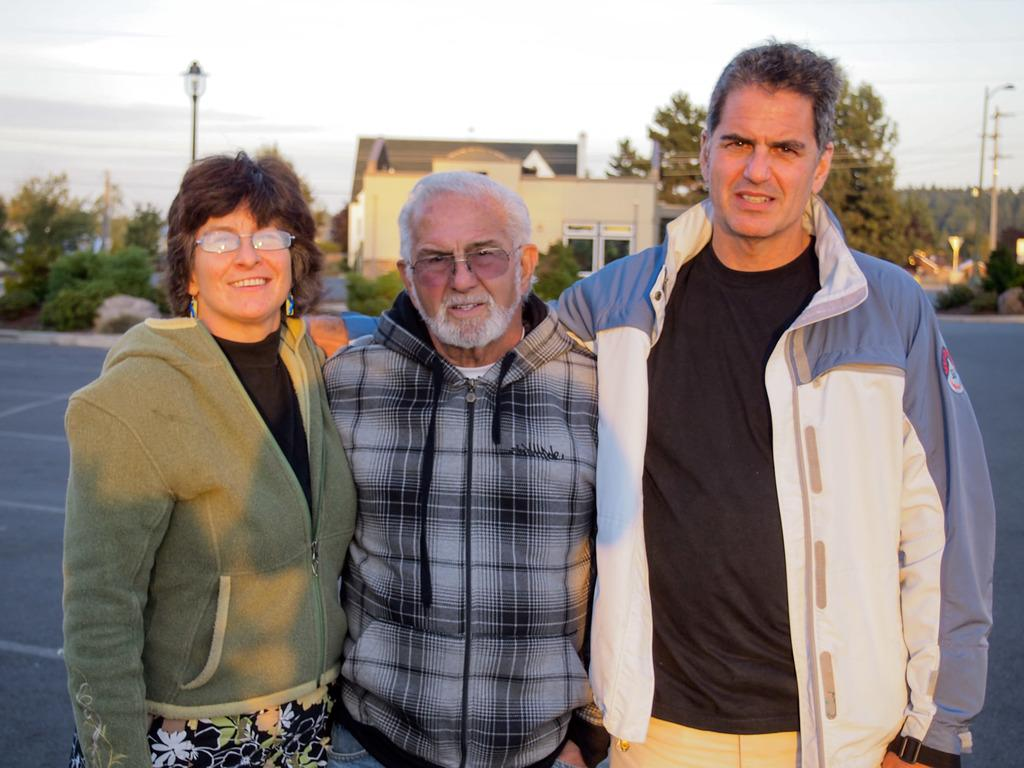How many people are in the image? There are three persons standing in the image. What can be seen in the background of the image? There is a house, trees, light poles, and the sky visible in the background of the image. What type of cup is being used to change the trail of the light poles in the image? There is no cup or trail of light poles present in the image. 